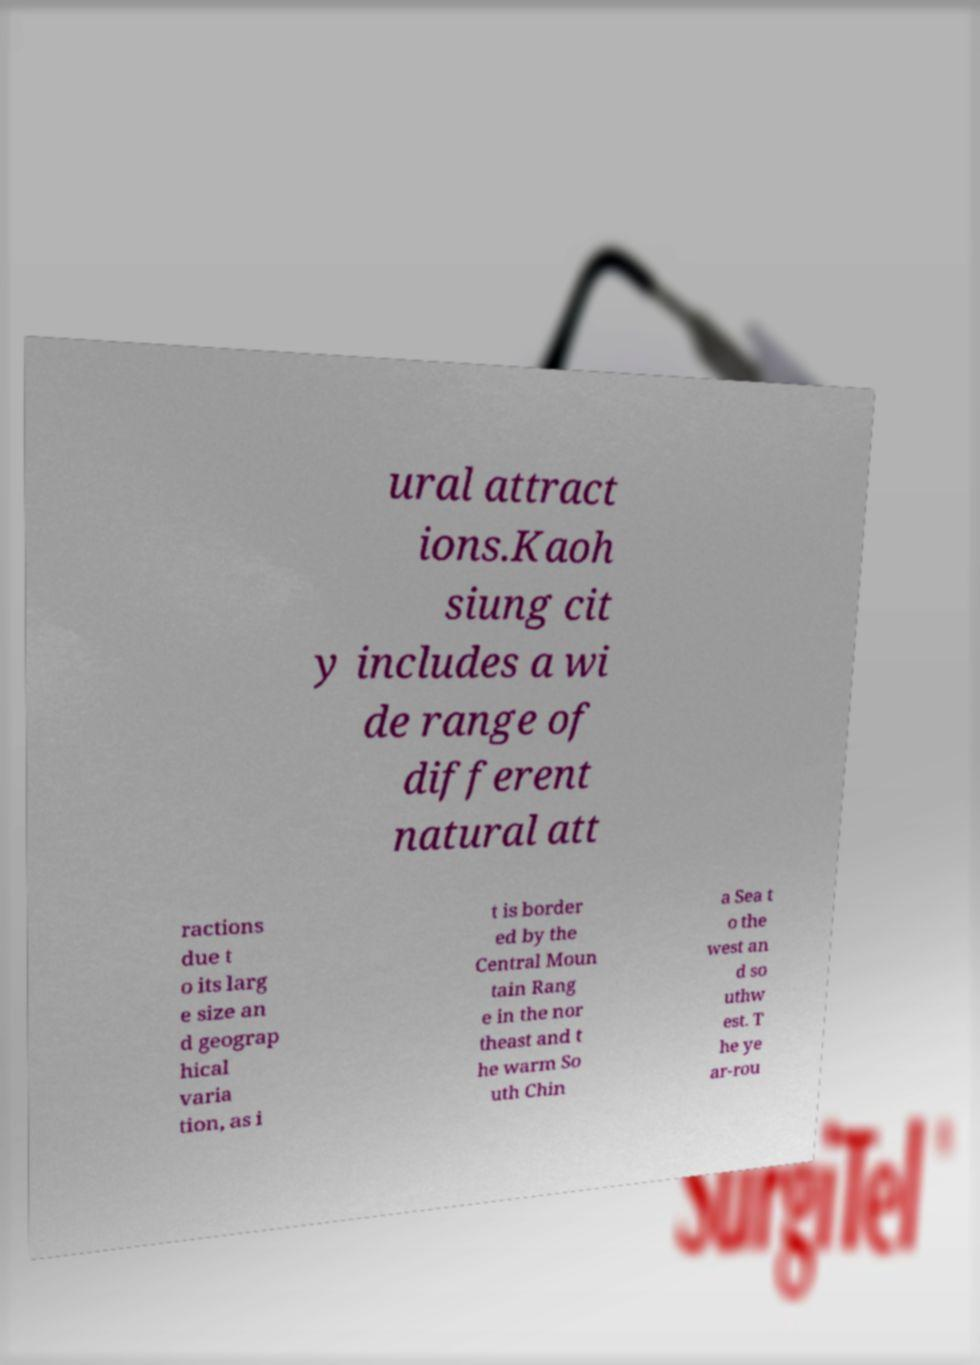Could you extract and type out the text from this image? ural attract ions.Kaoh siung cit y includes a wi de range of different natural att ractions due t o its larg e size an d geograp hical varia tion, as i t is border ed by the Central Moun tain Rang e in the nor theast and t he warm So uth Chin a Sea t o the west an d so uthw est. T he ye ar-rou 